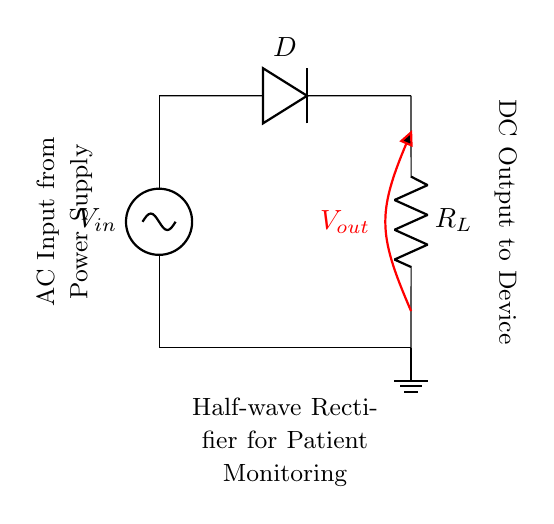What is the input type for this circuit? The input type is AC, as indicated by the AC source symbol in the circuit diagram. The symbol is labeled as "V in," which signifies it is providing an alternating current.
Answer: AC What component converts AC to DC? The component that converts AC to DC is the diode (labeled D) in the circuit. The diode allows current to flow in only one direction, effectively blocking half of the AC waveform and producing DC.
Answer: Diode What is the function of the load resistor in this circuit? The load resistor (labeled R L) in this circuit provides a path for current and determines the output voltage level and current based on the rectified input. It represents the load being powered by the circuit.
Answer: Provide load path What is the output voltage labeled as? The output voltage is labeled "V out" on the circuit diagram as indicated by the red line showing the output between the diode and the load resistor.
Answer: V out Why is this circuit called a half-wave rectifier? This circuit is called a half-wave rectifier because it only allows one half of the AC waveform (positive or negative) to pass through, effectively filtering out one half of the signal and converting it to DC. This is due to the diode's unidirectional conduction.
Answer: Half-wave rectifier What does the ground symbolize in this circuit? The ground symbol in this circuit indicates a common reference point for the circuit, providing a return path for electric current. It ensures that the circuit has a stable reference for voltage levels throughout the system.
Answer: Ground reference How does the diode affect the output waveform? The diode affects the output waveform by clipping off the negative portion of the input AC waveform, allowing only the positive portion to reach the output. This results in a pulsating DC waveform rather than a smooth one.
Answer: Clipping negative half 